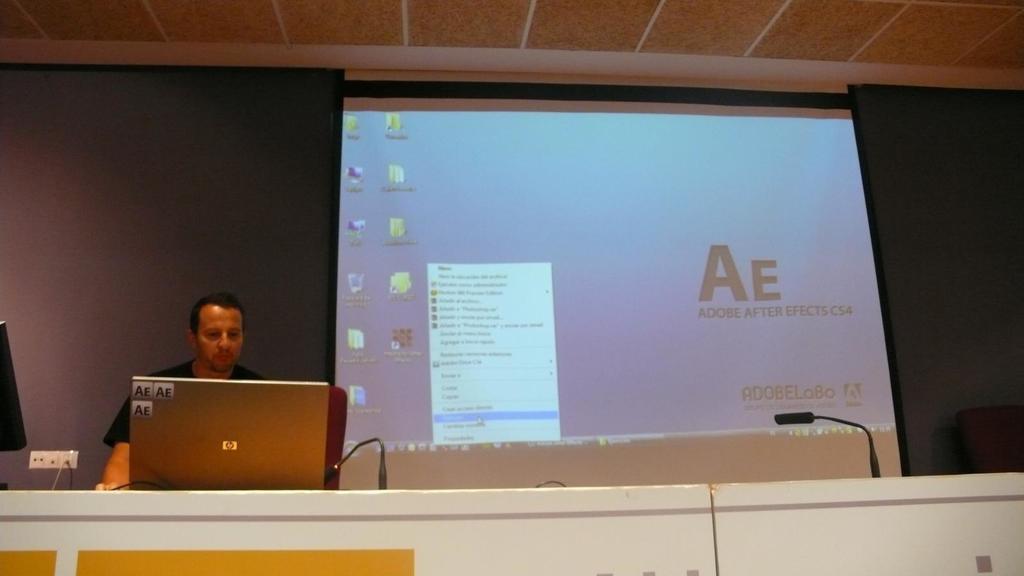How would you summarize this image in a sentence or two? In this image we can see a person in front of the monitor screen which is on the counter. We can also see the miles, switchboard, screen with icons and text and also the wall. At the top we can see the ceiling. 